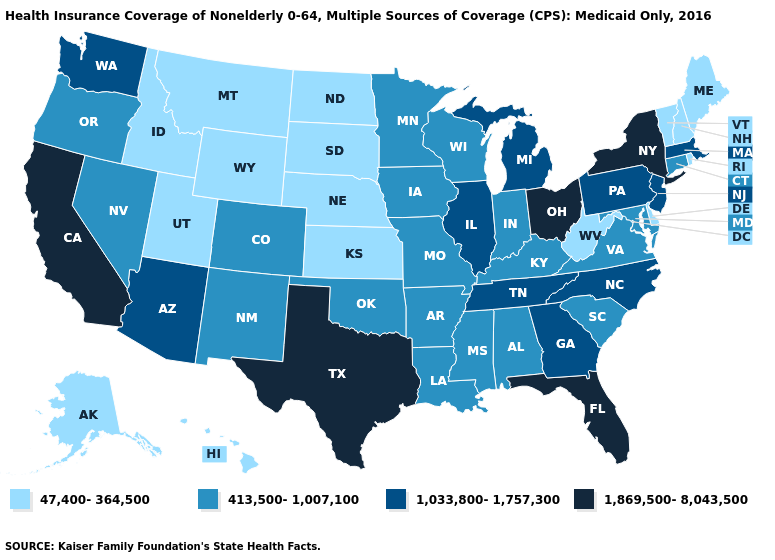Among the states that border New York , does Connecticut have the highest value?
Quick response, please. No. Among the states that border Delaware , which have the highest value?
Keep it brief. New Jersey, Pennsylvania. What is the lowest value in the USA?
Be succinct. 47,400-364,500. What is the highest value in the MidWest ?
Quick response, please. 1,869,500-8,043,500. Which states hav the highest value in the West?
Concise answer only. California. What is the lowest value in the MidWest?
Write a very short answer. 47,400-364,500. Does Illinois have a lower value than Ohio?
Write a very short answer. Yes. Name the states that have a value in the range 413,500-1,007,100?
Write a very short answer. Alabama, Arkansas, Colorado, Connecticut, Indiana, Iowa, Kentucky, Louisiana, Maryland, Minnesota, Mississippi, Missouri, Nevada, New Mexico, Oklahoma, Oregon, South Carolina, Virginia, Wisconsin. Name the states that have a value in the range 47,400-364,500?
Give a very brief answer. Alaska, Delaware, Hawaii, Idaho, Kansas, Maine, Montana, Nebraska, New Hampshire, North Dakota, Rhode Island, South Dakota, Utah, Vermont, West Virginia, Wyoming. Name the states that have a value in the range 1,869,500-8,043,500?
Short answer required. California, Florida, New York, Ohio, Texas. Does Wyoming have a higher value than South Carolina?
Short answer required. No. Among the states that border Kansas , does Colorado have the highest value?
Answer briefly. Yes. Name the states that have a value in the range 1,033,800-1,757,300?
Write a very short answer. Arizona, Georgia, Illinois, Massachusetts, Michigan, New Jersey, North Carolina, Pennsylvania, Tennessee, Washington. What is the value of New Jersey?
Keep it brief. 1,033,800-1,757,300. Among the states that border Kansas , which have the lowest value?
Concise answer only. Nebraska. 